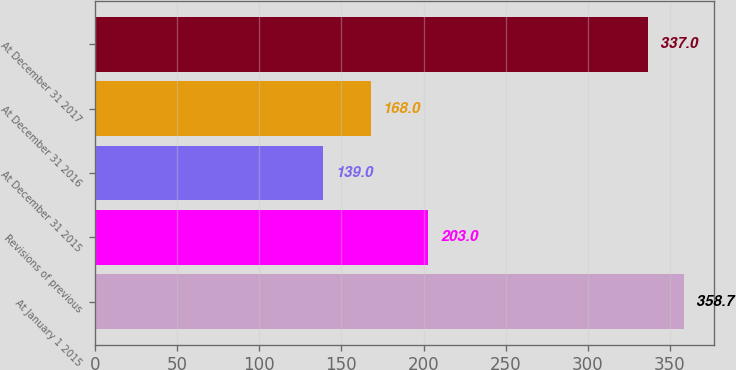Convert chart to OTSL. <chart><loc_0><loc_0><loc_500><loc_500><bar_chart><fcel>At January 1 2015<fcel>Revisions of previous<fcel>At December 31 2015<fcel>At December 31 2016<fcel>At December 31 2017<nl><fcel>358.7<fcel>203<fcel>139<fcel>168<fcel>337<nl></chart> 